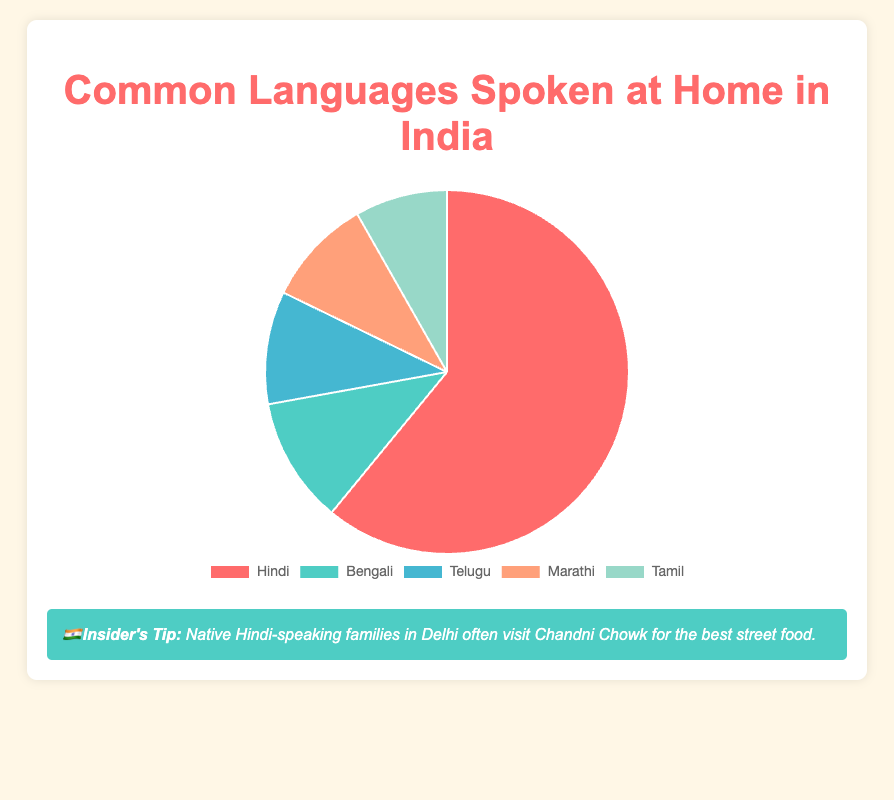What is the percentage of homes where Hindi is spoken? According to the figure, Hindi is spoken in 43.63% of homes.
Answer: 43.63% Which language is spoken at home by the smallest percentage of people? Comparing the percentages of all languages shown in the pie chart, Tamil has the smallest percentage at 5.89%.
Answer: Tamil What is the total percentage of homes where Bengali and Telugu are spoken? The percentage of homes where Bengali is spoken is 8.03%, and for Telugu, it is 7.19%. Adding these two percentages, 8.03 + 7.19 = 15.22%.
Answer: 15.22% Which language is more commonly spoken at home, Marathi or Tamil? The percentage of homes where Marathi is spoken is 6.86%, and for Tamil, it is 5.89%. Since 6.86% is greater than 5.89%, Marathi is more commonly spoken at home.
Answer: Marathi How much more common is Hindi compared to Telugu? The percentage of homes where Hindi is spoken is 43.63%, and for Telugu, it is 7.19%. Subtracting the smaller percentage from the larger one, 43.63 - 7.19 = 36.44%.
Answer: 36.44% What is the median percentage of homes where these languages are spoken? Arranging the percentages in ascending order: 5.89% (Tamil), 6.86% (Marathi), 7.19% (Telugu), 8.03% (Bengali), and 43.63% (Hindi), the median value, which is the middle one in this ordered list, is 7.19% (Telugu).
Answer: 7.19% Arrange the languages from most to least spoken at home. Referring to the percentages on the pie chart: Hindi (43.63%), Bengali (8.03%), Telugu (7.19%), Marathi (6.86%), Tamil (5.89%).
Answer: Hindi, Bengali, Telugu, Marathi, Tamil Which language’s section of the pie chart is represented in red? Based on the color description provided, the language represented in red is Hindi.
Answer: Hindi What percentage of homes in India does not speak Hindi, Bengali, Telugu, Marathi, or Tamil? The combined percentage of homes speaking these five languages (43.63% + 8.03% + 7.19% + 6.86% + 5.89%) is 71.60%. Subtracting this from 100%, 100 - 71.60 = 28.40%.
Answer: 28.40% Which languages have a lower percentage spoken at home than Marathi? Marathi has a percentage of 6.86%. Both Tamil (5.89%) and Telugu (7.19%) fit this category.
Answer: Tamil 